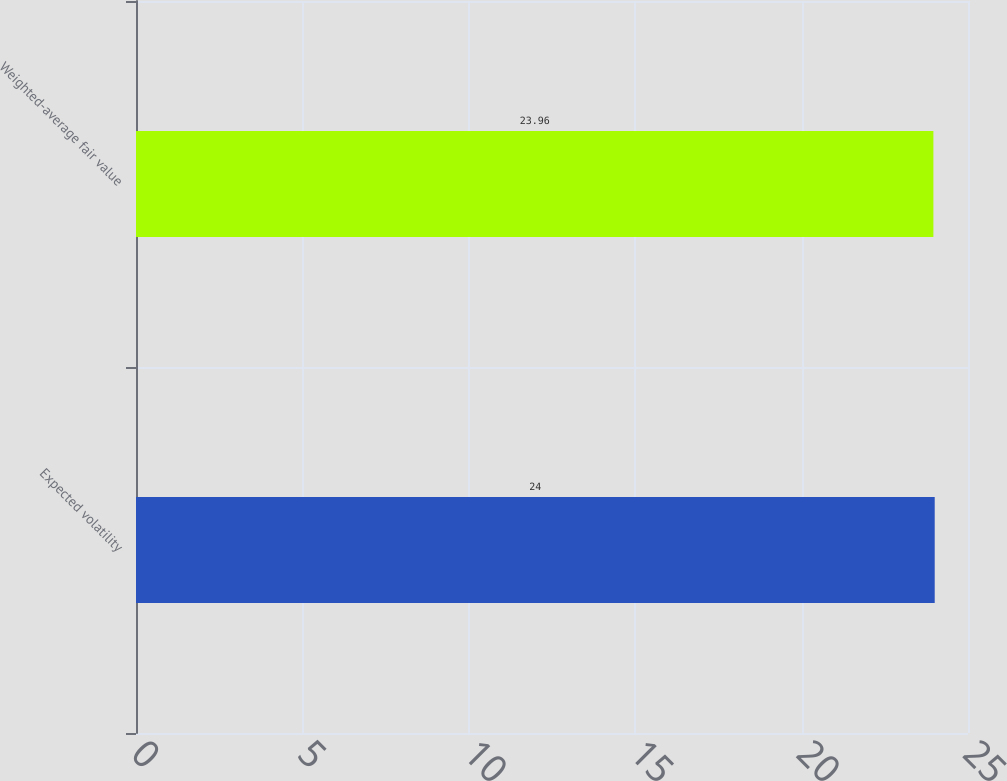<chart> <loc_0><loc_0><loc_500><loc_500><bar_chart><fcel>Expected volatility<fcel>Weighted-average fair value<nl><fcel>24<fcel>23.96<nl></chart> 